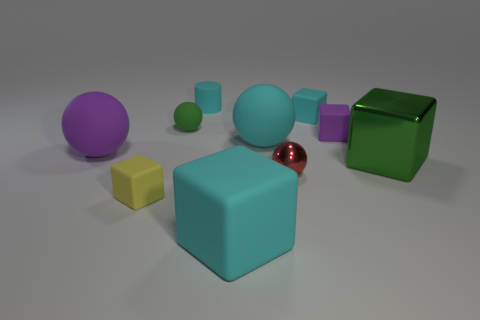Subtract all small green rubber spheres. How many spheres are left? 3 Subtract 1 blocks. How many blocks are left? 4 Subtract all green spheres. How many spheres are left? 3 Subtract all green blocks. Subtract all red spheres. How many blocks are left? 4 Subtract all cylinders. How many objects are left? 9 Add 5 green metal blocks. How many green metal blocks are left? 6 Add 3 big red shiny blocks. How many big red shiny blocks exist? 3 Subtract 0 brown cubes. How many objects are left? 10 Subtract all cyan cubes. Subtract all tiny objects. How many objects are left? 2 